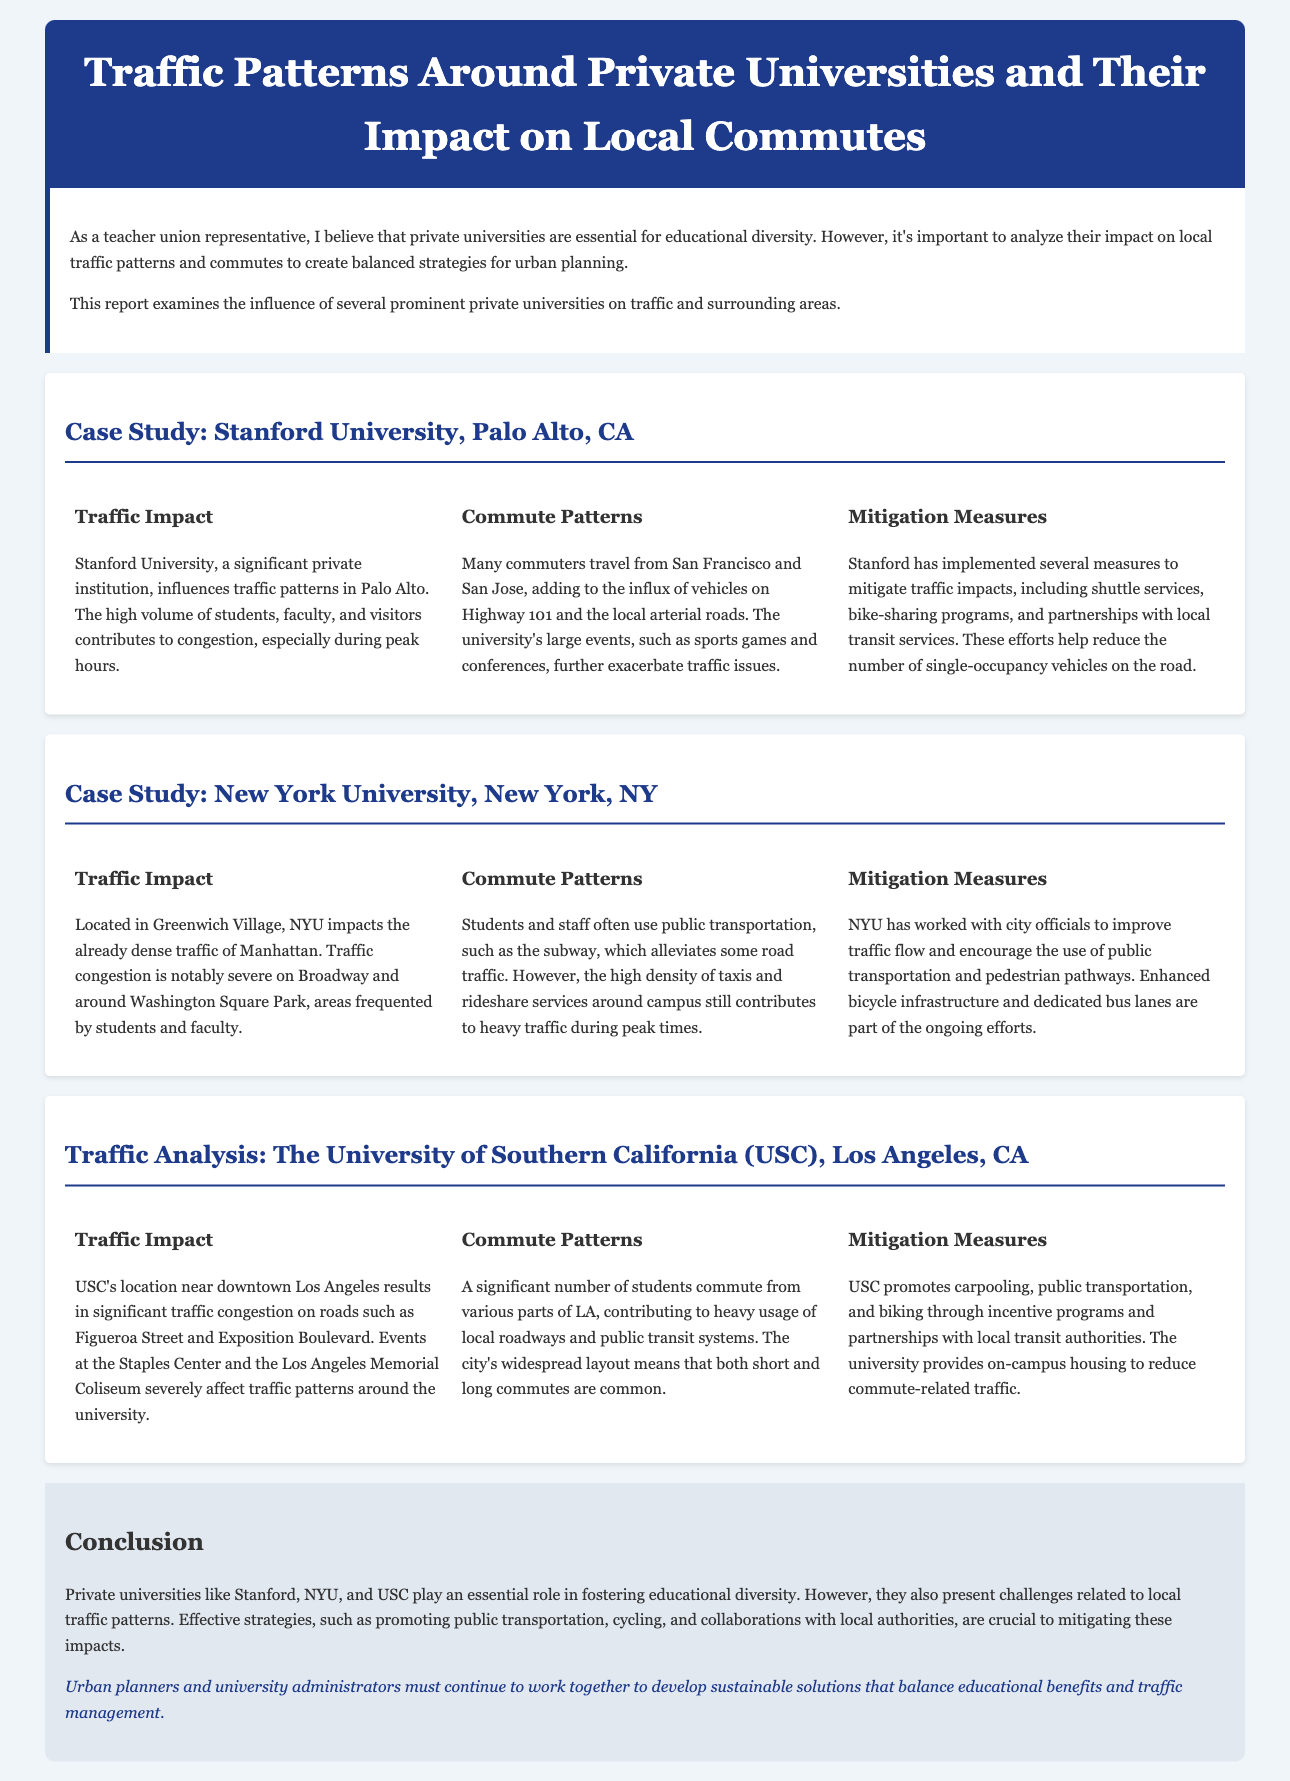What is the title of the report? The title of the report is stated at the top of the document.
Answer: Traffic Patterns Around Private Universities and Their Impact on Local Commutes Which university is mentioned as located in Greenwich Village? The university located in Greenwich Village is explicitly mentioned in the document.
Answer: New York University What traffic congestion issues are mentioned for USC? The document specifically discusses traffic congestion on certain roads due to USC.
Answer: Figueroa Street and Exposition Boulevard What type of transportation does NYU encourage? The document outlines the modes of transportation that NYU promotes in the traffic report.
Answer: Public transportation How many universities are discussed in the case studies? The report includes detailed case studies of different universities, which can be counted.
Answer: Three What is a mitigation measure implemented by Stanford University? The report provides examples of measures taken by Stanford to address traffic issues.
Answer: Shuttle services What traffic impact is noted for Stanford University? The document discusses the specific traffic impacts associated with Stanford University.
Answer: Congestion What major transportation system is used by many students at NYU? The document identifies the public transport system frequently used by students and staff at NYU.
Answer: Subway 